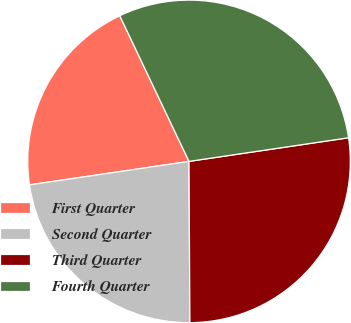Convert chart to OTSL. <chart><loc_0><loc_0><loc_500><loc_500><pie_chart><fcel>First Quarter<fcel>Second Quarter<fcel>Third Quarter<fcel>Fourth Quarter<nl><fcel>20.26%<fcel>22.76%<fcel>27.25%<fcel>29.72%<nl></chart> 